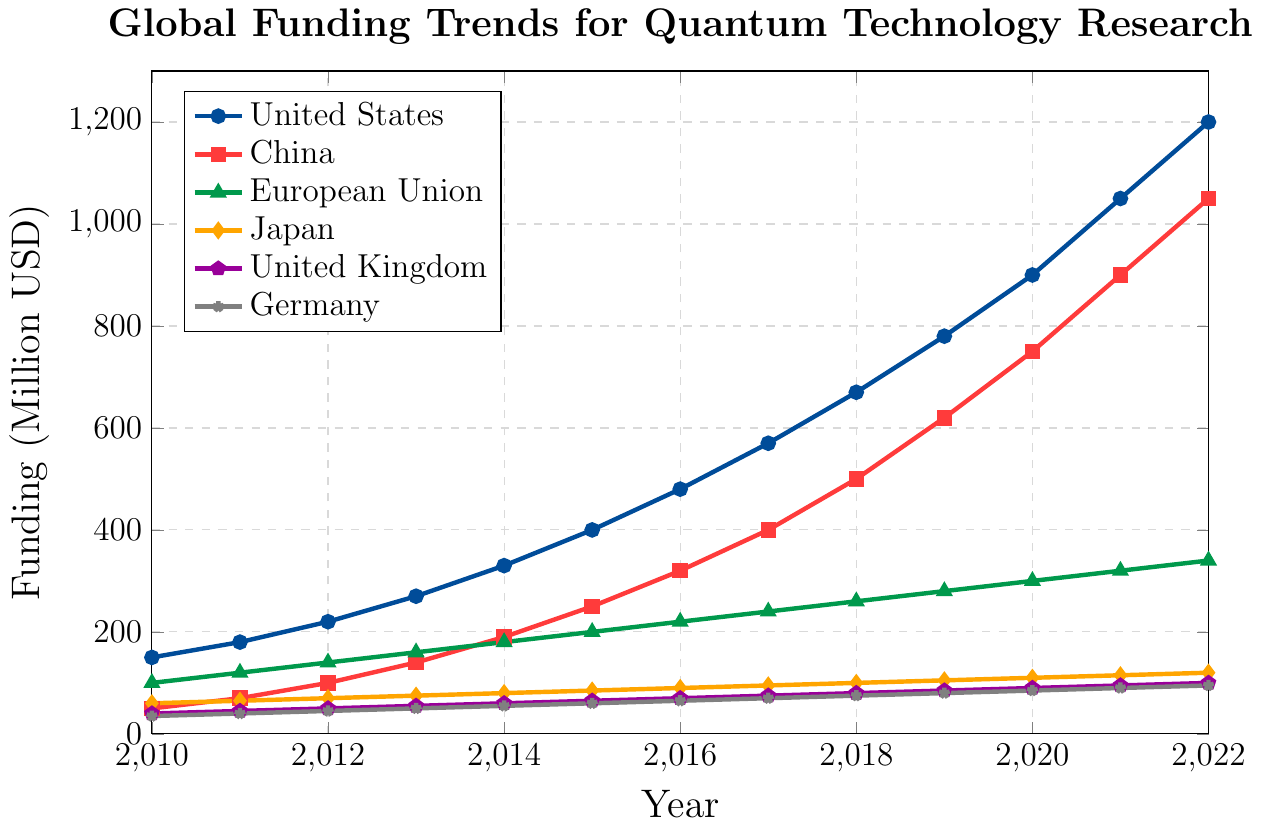What is the funding value for the United States in 2020? The funding value for the United States in 2020 can be found by locating the data point above the year 2020 on the horizontal axis and tracking the vertical position for the United States' line (blue line).
Answer: 900 Which country saw the highest funding increase from 2010 to 2022? To determine this, find the difference in funding from 2010 to 2022 for each country and compare the results.
Answer: United States Between which consecutive years did China see the largest funding increase? Calculate the annual increment in funding values for China and identify the two consecutive years with the largest increase.
Answer: 2019 to 2020 How does Germany's funding in 2021 compare to the European Union's funding in 2010? Locate Germany's funding value for 2021 and compare it to the European Union's funding value for 2010.
Answer: Germany's funding in 2021 is higher What is the average annual funding for Japan from 2010 to 2022? Sum Japan's annual funding values from 2010 to 2022 and divide by the number of years. (60+65+70+75+80+85+90+95+100+105+110+115+120)/13
Answer: 87.31 Which country had the lowest funding in 2014, and what was the value? Check the funding values for all countries in 2014 and identify the smallest one.
Answer: Germany, 55 What is the total funding for the European Union from 2010 to 2022? Sum the annual funding values for the European Union from 2010 to 2022. (100+120+140+160+180+200+220+240+260+280+300+320+340)
Answer: 2860 How does the growth trend of the United Kingdom compare to that of the United States between 2010 and 2022? Compare the rate of increase in funding between the United Kingdom and the United States by examining the steepness and shape of their respective lines.
Answer: United States shows a steeper and more rapid increase What is the ratio of China's funding to Germany's funding in 2022? Divide China's funding in 2022 by Germany's funding in 2022. 1050/95
Answer: 11.05 Which country consistently had the lowest funding throughout the given years? Review the funding values year by year for each country to identify which country had the lowest values across all years.
Answer: Germany 